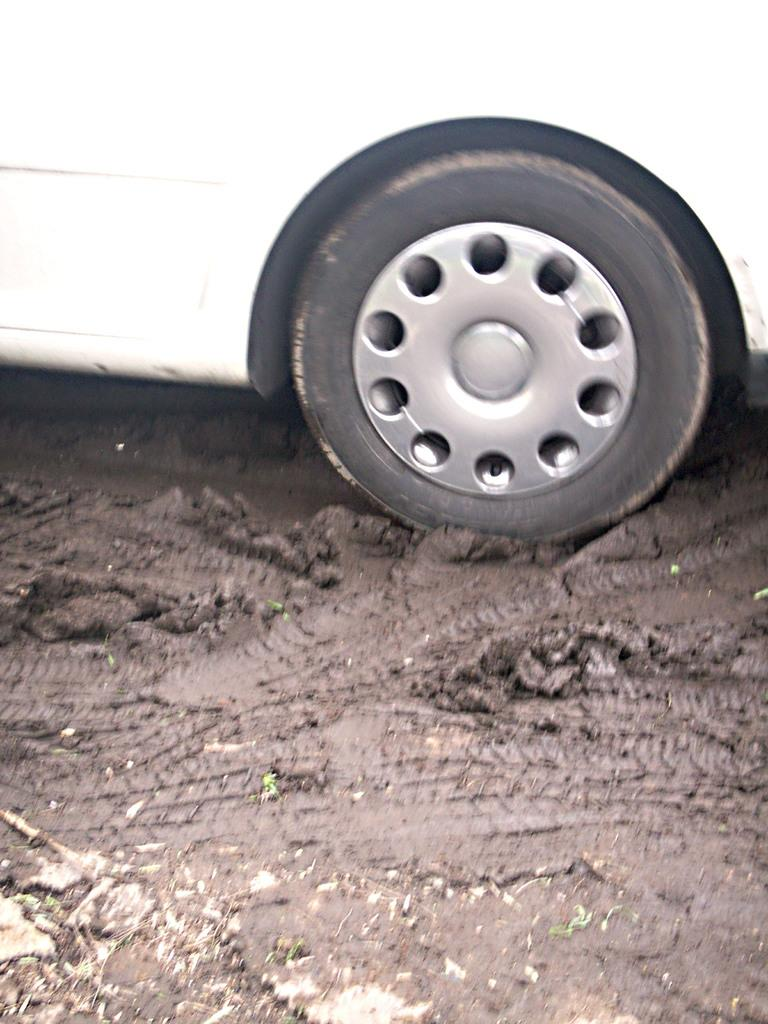What is the main subject in the image? There is a vehicle in the image. What is the condition of the ground in the image? There is mud at the bottom of the image. How much was the payment for the vehicle in the image? There is no information about payment in the image, as it only shows a vehicle and muddy ground. 